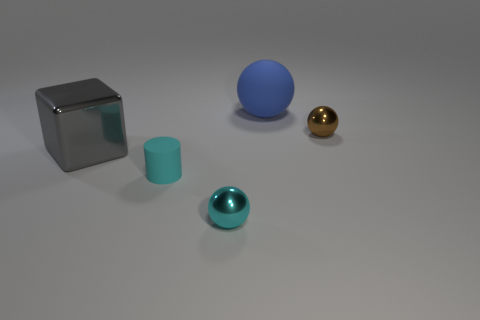Subtract all shiny balls. How many balls are left? 1 Add 3 blocks. How many objects exist? 8 Subtract all cyan balls. How many balls are left? 2 Subtract all spheres. How many objects are left? 2 Subtract 2 spheres. How many spheres are left? 1 Subtract all brown cubes. How many blue spheres are left? 1 Subtract all red cylinders. Subtract all brown cubes. How many cylinders are left? 1 Subtract all large gray blocks. Subtract all spheres. How many objects are left? 1 Add 3 large blue matte objects. How many large blue matte objects are left? 4 Add 5 small yellow metal cylinders. How many small yellow metal cylinders exist? 5 